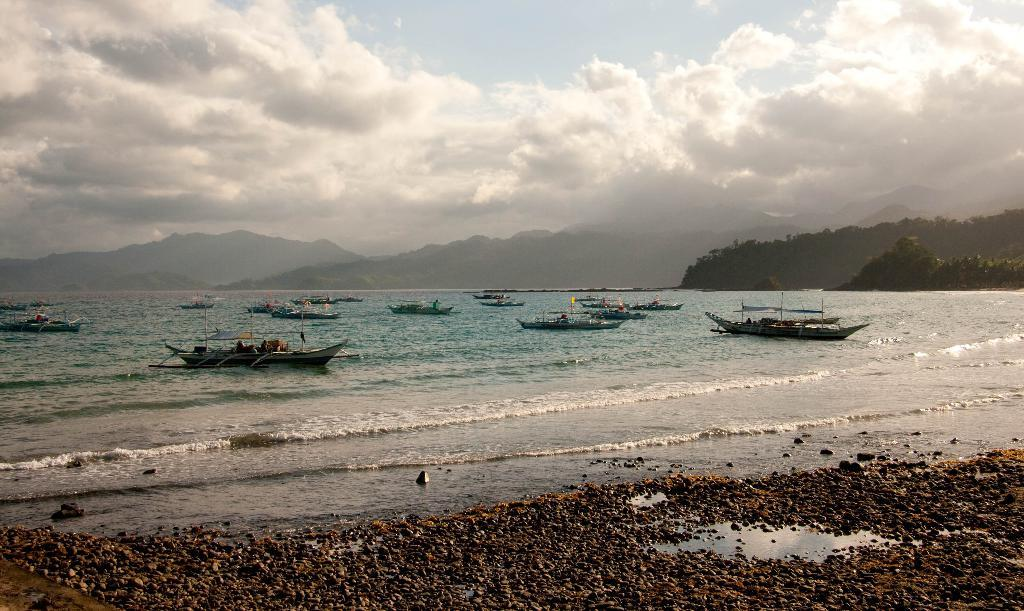What is happening in the center of the image? There are boats sailing on water in the image. Where are the boats located in relation to the image? The boats are in the center of the image. What type of vegetation is on the right side of the image? There are trees on the right side of the image. What can be seen in the background of the image? There are mountains in the background of the image. What is the condition of the sky in the image? The sky is cloudy in the image. What type of loss is being experienced by the boats in the image? There is no indication of any loss being experienced by the boats in the image. What fictional elements can be seen in the image? There are no fictional elements present in the image; it depicts real-life boats sailing on water. 